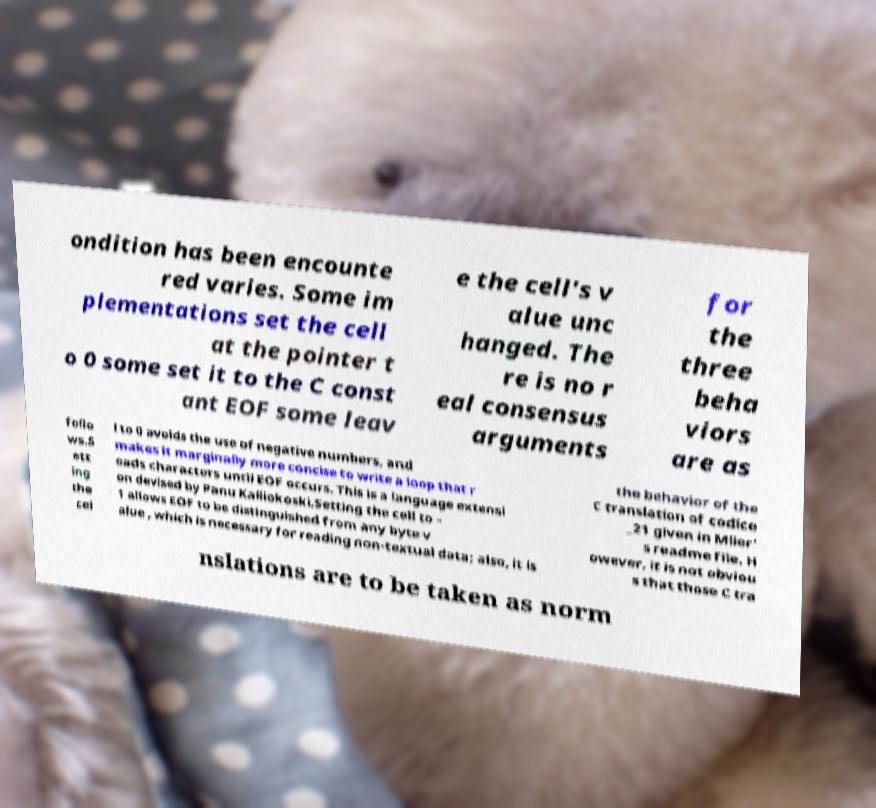Please identify and transcribe the text found in this image. ondition has been encounte red varies. Some im plementations set the cell at the pointer t o 0 some set it to the C const ant EOF some leav e the cell's v alue unc hanged. The re is no r eal consensus arguments for the three beha viors are as follo ws.S ett ing the cel l to 0 avoids the use of negative numbers, and makes it marginally more concise to write a loop that r eads characters until EOF occurs. This is a language extensi on devised by Panu Kalliokoski.Setting the cell to - 1 allows EOF to be distinguished from any byte v alue , which is necessary for reading non-textual data; also, it is the behavior of the C translation of codice _21 given in Mller' s readme file. H owever, it is not obviou s that those C tra nslations are to be taken as norm 